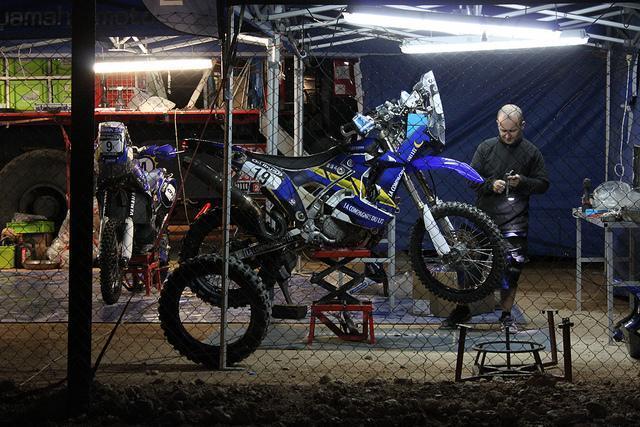How many green objects are in the picture?
Give a very brief answer. 1. How many motorcycles can be seen?
Give a very brief answer. 2. 